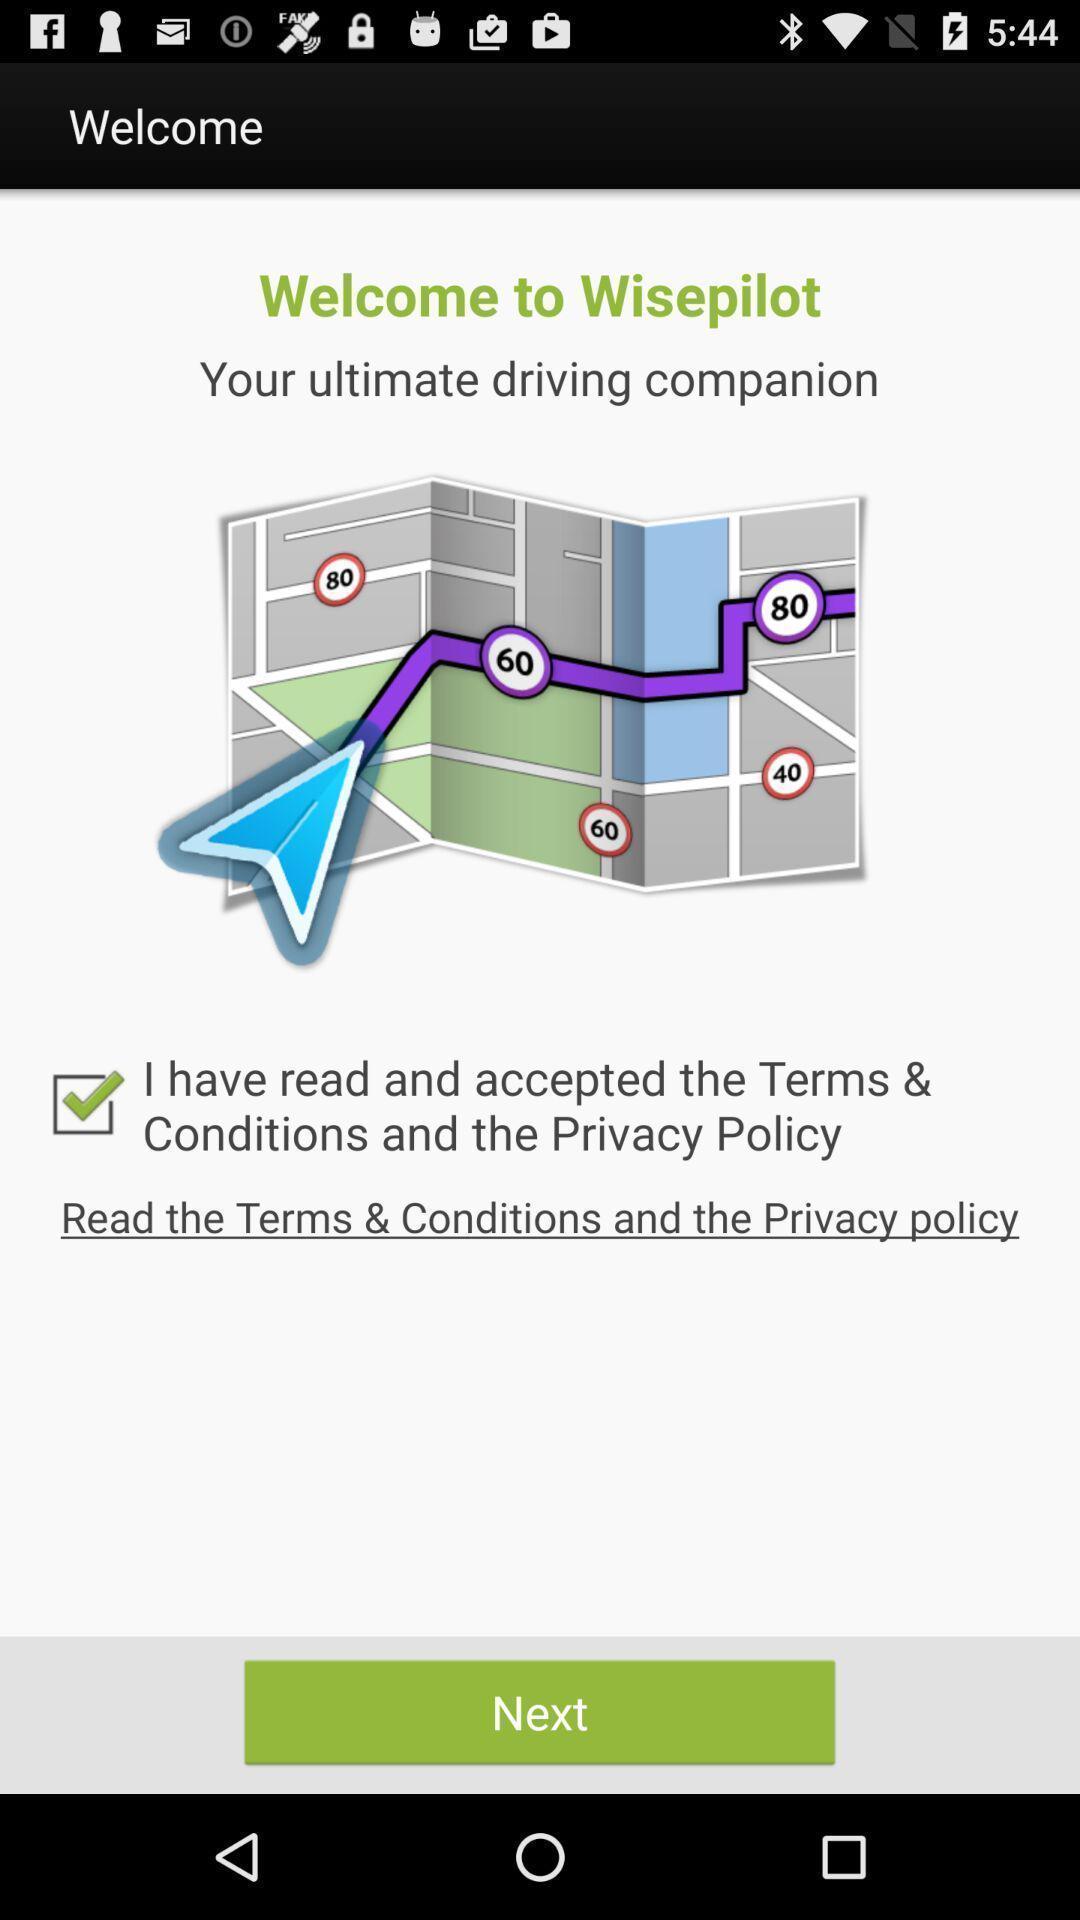Tell me what you see in this picture. Welcome page. 